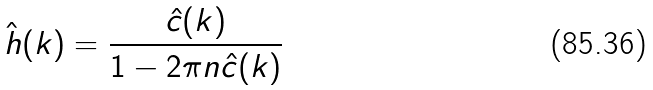Convert formula to latex. <formula><loc_0><loc_0><loc_500><loc_500>\hat { h } ( k ) = \frac { \hat { c } ( k ) } { 1 - 2 \pi n \hat { c } ( k ) }</formula> 